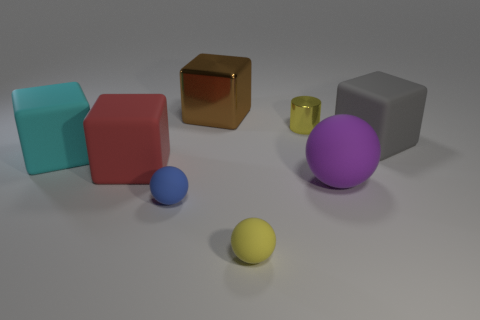The sphere that is the same color as the tiny cylinder is what size?
Provide a succinct answer. Small. There is a matte object that is the same color as the cylinder; what shape is it?
Provide a short and direct response. Sphere. Is there anything else that is the same color as the metal cylinder?
Make the answer very short. Yes. There is a shiny cylinder; is its color the same as the tiny matte ball to the right of the large brown thing?
Provide a short and direct response. Yes. What is the yellow thing that is in front of the big gray cube made of?
Your response must be concise. Rubber. What number of other objects are the same size as the purple matte ball?
Your response must be concise. 4. There is a red object; does it have the same size as the blue rubber sphere that is right of the red object?
Provide a succinct answer. No. The tiny thing behind the large cube to the right of the shiny object left of the yellow cylinder is what shape?
Ensure brevity in your answer.  Cylinder. Is the number of red rubber blocks less than the number of small rubber things?
Keep it short and to the point. Yes. There is a tiny blue sphere; are there any yellow things on the left side of it?
Offer a terse response. No. 